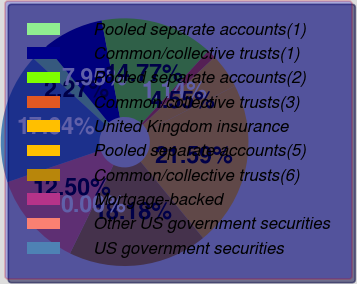Convert chart. <chart><loc_0><loc_0><loc_500><loc_500><pie_chart><fcel>Pooled separate accounts(1)<fcel>Common/collective trusts(1)<fcel>Pooled separate accounts(2)<fcel>Common/collective trusts(3)<fcel>United Kingdom insurance<fcel>Pooled separate accounts(5)<fcel>Common/collective trusts(6)<fcel>Mortgage-backed<fcel>Other US government securities<fcel>US government securities<nl><fcel>2.27%<fcel>7.95%<fcel>14.77%<fcel>1.14%<fcel>4.55%<fcel>21.59%<fcel>18.18%<fcel>0.0%<fcel>12.5%<fcel>17.04%<nl></chart> 